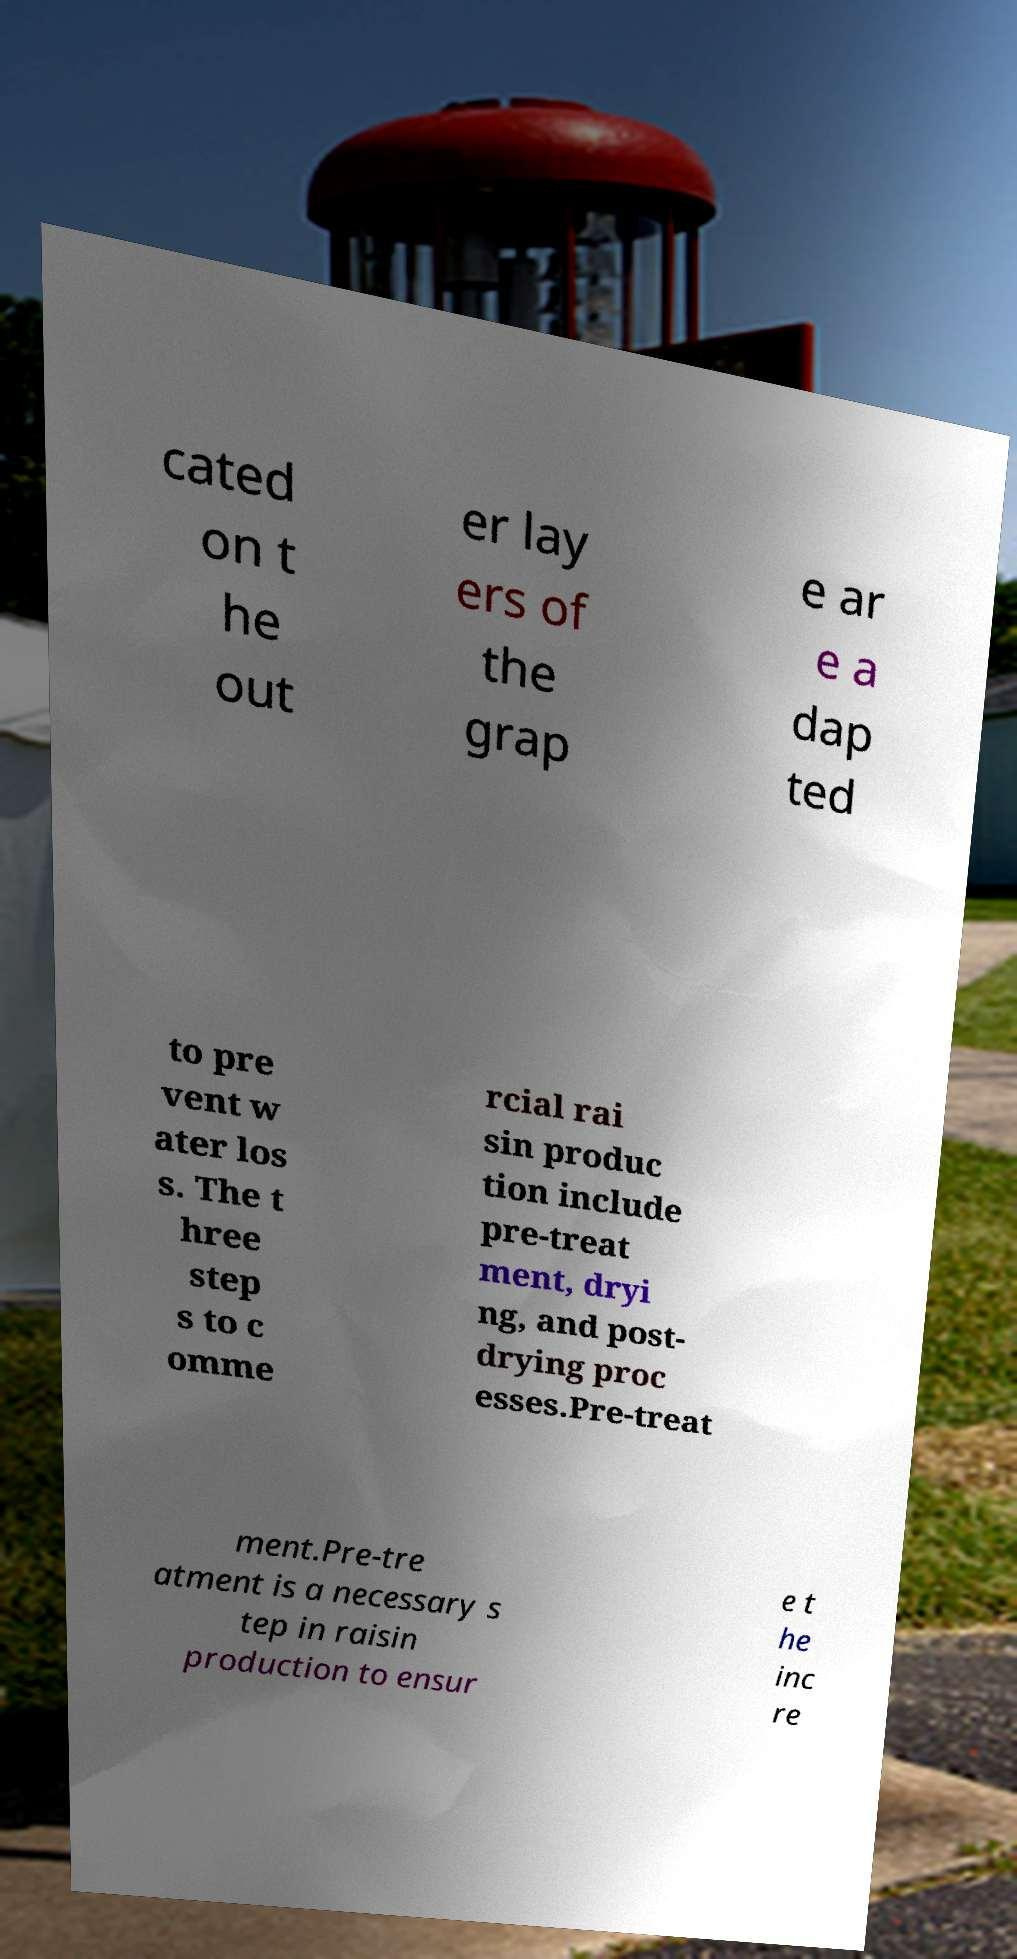For documentation purposes, I need the text within this image transcribed. Could you provide that? cated on t he out er lay ers of the grap e ar e a dap ted to pre vent w ater los s. The t hree step s to c omme rcial rai sin produc tion include pre-treat ment, dryi ng, and post- drying proc esses.Pre-treat ment.Pre-tre atment is a necessary s tep in raisin production to ensur e t he inc re 